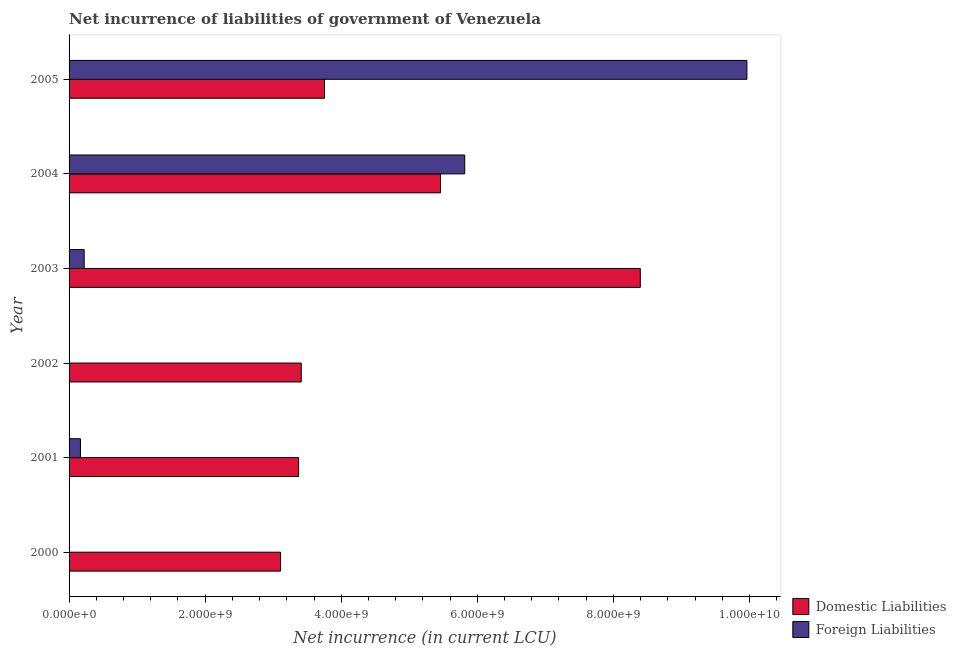How many different coloured bars are there?
Your answer should be very brief. 2. Are the number of bars on each tick of the Y-axis equal?
Your response must be concise. No. How many bars are there on the 1st tick from the top?
Your answer should be very brief. 2. How many bars are there on the 6th tick from the bottom?
Give a very brief answer. 2. In how many cases, is the number of bars for a given year not equal to the number of legend labels?
Offer a very short reply. 2. What is the net incurrence of domestic liabilities in 2000?
Give a very brief answer. 3.11e+09. Across all years, what is the maximum net incurrence of foreign liabilities?
Ensure brevity in your answer.  9.96e+09. Across all years, what is the minimum net incurrence of domestic liabilities?
Provide a succinct answer. 3.11e+09. In which year was the net incurrence of foreign liabilities maximum?
Offer a terse response. 2005. What is the total net incurrence of foreign liabilities in the graph?
Make the answer very short. 1.62e+1. What is the difference between the net incurrence of domestic liabilities in 2000 and that in 2004?
Offer a terse response. -2.35e+09. What is the difference between the net incurrence of foreign liabilities in 2003 and the net incurrence of domestic liabilities in 2002?
Ensure brevity in your answer.  -3.19e+09. What is the average net incurrence of domestic liabilities per year?
Your answer should be very brief. 4.58e+09. In the year 2004, what is the difference between the net incurrence of foreign liabilities and net incurrence of domestic liabilities?
Provide a succinct answer. 3.55e+08. In how many years, is the net incurrence of domestic liabilities greater than 6400000000 LCU?
Keep it short and to the point. 1. Is the difference between the net incurrence of foreign liabilities in 2003 and 2004 greater than the difference between the net incurrence of domestic liabilities in 2003 and 2004?
Offer a terse response. No. What is the difference between the highest and the second highest net incurrence of domestic liabilities?
Your answer should be very brief. 2.94e+09. What is the difference between the highest and the lowest net incurrence of domestic liabilities?
Give a very brief answer. 5.29e+09. In how many years, is the net incurrence of domestic liabilities greater than the average net incurrence of domestic liabilities taken over all years?
Offer a terse response. 2. Is the sum of the net incurrence of foreign liabilities in 2003 and 2005 greater than the maximum net incurrence of domestic liabilities across all years?
Offer a very short reply. Yes. How many bars are there?
Your response must be concise. 10. What is the difference between two consecutive major ticks on the X-axis?
Your response must be concise. 2.00e+09. Are the values on the major ticks of X-axis written in scientific E-notation?
Provide a succinct answer. Yes. Does the graph contain grids?
Your answer should be very brief. No. How many legend labels are there?
Your answer should be compact. 2. What is the title of the graph?
Ensure brevity in your answer.  Net incurrence of liabilities of government of Venezuela. What is the label or title of the X-axis?
Ensure brevity in your answer.  Net incurrence (in current LCU). What is the label or title of the Y-axis?
Your response must be concise. Year. What is the Net incurrence (in current LCU) in Domestic Liabilities in 2000?
Keep it short and to the point. 3.11e+09. What is the Net incurrence (in current LCU) of Foreign Liabilities in 2000?
Provide a succinct answer. 0. What is the Net incurrence (in current LCU) of Domestic Liabilities in 2001?
Keep it short and to the point. 3.37e+09. What is the Net incurrence (in current LCU) of Foreign Liabilities in 2001?
Give a very brief answer. 1.68e+08. What is the Net incurrence (in current LCU) in Domestic Liabilities in 2002?
Give a very brief answer. 3.41e+09. What is the Net incurrence (in current LCU) of Domestic Liabilities in 2003?
Your response must be concise. 8.40e+09. What is the Net incurrence (in current LCU) in Foreign Liabilities in 2003?
Keep it short and to the point. 2.22e+08. What is the Net incurrence (in current LCU) of Domestic Liabilities in 2004?
Give a very brief answer. 5.46e+09. What is the Net incurrence (in current LCU) of Foreign Liabilities in 2004?
Offer a very short reply. 5.81e+09. What is the Net incurrence (in current LCU) of Domestic Liabilities in 2005?
Ensure brevity in your answer.  3.75e+09. What is the Net incurrence (in current LCU) in Foreign Liabilities in 2005?
Ensure brevity in your answer.  9.96e+09. Across all years, what is the maximum Net incurrence (in current LCU) in Domestic Liabilities?
Your answer should be very brief. 8.40e+09. Across all years, what is the maximum Net incurrence (in current LCU) of Foreign Liabilities?
Your response must be concise. 9.96e+09. Across all years, what is the minimum Net incurrence (in current LCU) in Domestic Liabilities?
Your answer should be compact. 3.11e+09. Across all years, what is the minimum Net incurrence (in current LCU) in Foreign Liabilities?
Give a very brief answer. 0. What is the total Net incurrence (in current LCU) in Domestic Liabilities in the graph?
Give a very brief answer. 2.75e+1. What is the total Net incurrence (in current LCU) of Foreign Liabilities in the graph?
Ensure brevity in your answer.  1.62e+1. What is the difference between the Net incurrence (in current LCU) of Domestic Liabilities in 2000 and that in 2001?
Your answer should be compact. -2.65e+08. What is the difference between the Net incurrence (in current LCU) of Domestic Liabilities in 2000 and that in 2002?
Ensure brevity in your answer.  -3.04e+08. What is the difference between the Net incurrence (in current LCU) of Domestic Liabilities in 2000 and that in 2003?
Provide a short and direct response. -5.29e+09. What is the difference between the Net incurrence (in current LCU) in Domestic Liabilities in 2000 and that in 2004?
Keep it short and to the point. -2.35e+09. What is the difference between the Net incurrence (in current LCU) in Domestic Liabilities in 2000 and that in 2005?
Offer a very short reply. -6.45e+08. What is the difference between the Net incurrence (in current LCU) of Domestic Liabilities in 2001 and that in 2002?
Your answer should be very brief. -3.84e+07. What is the difference between the Net incurrence (in current LCU) of Domestic Liabilities in 2001 and that in 2003?
Give a very brief answer. -5.02e+09. What is the difference between the Net incurrence (in current LCU) in Foreign Liabilities in 2001 and that in 2003?
Your response must be concise. -5.43e+07. What is the difference between the Net incurrence (in current LCU) of Domestic Liabilities in 2001 and that in 2004?
Your answer should be compact. -2.09e+09. What is the difference between the Net incurrence (in current LCU) of Foreign Liabilities in 2001 and that in 2004?
Provide a short and direct response. -5.65e+09. What is the difference between the Net incurrence (in current LCU) of Domestic Liabilities in 2001 and that in 2005?
Offer a very short reply. -3.80e+08. What is the difference between the Net incurrence (in current LCU) of Foreign Liabilities in 2001 and that in 2005?
Keep it short and to the point. -9.79e+09. What is the difference between the Net incurrence (in current LCU) of Domestic Liabilities in 2002 and that in 2003?
Ensure brevity in your answer.  -4.98e+09. What is the difference between the Net incurrence (in current LCU) in Domestic Liabilities in 2002 and that in 2004?
Your answer should be very brief. -2.05e+09. What is the difference between the Net incurrence (in current LCU) of Domestic Liabilities in 2002 and that in 2005?
Give a very brief answer. -3.42e+08. What is the difference between the Net incurrence (in current LCU) in Domestic Liabilities in 2003 and that in 2004?
Ensure brevity in your answer.  2.94e+09. What is the difference between the Net incurrence (in current LCU) of Foreign Liabilities in 2003 and that in 2004?
Your response must be concise. -5.59e+09. What is the difference between the Net incurrence (in current LCU) of Domestic Liabilities in 2003 and that in 2005?
Offer a very short reply. 4.64e+09. What is the difference between the Net incurrence (in current LCU) of Foreign Liabilities in 2003 and that in 2005?
Make the answer very short. -9.74e+09. What is the difference between the Net incurrence (in current LCU) in Domestic Liabilities in 2004 and that in 2005?
Your response must be concise. 1.71e+09. What is the difference between the Net incurrence (in current LCU) in Foreign Liabilities in 2004 and that in 2005?
Your answer should be compact. -4.15e+09. What is the difference between the Net incurrence (in current LCU) of Domestic Liabilities in 2000 and the Net incurrence (in current LCU) of Foreign Liabilities in 2001?
Make the answer very short. 2.94e+09. What is the difference between the Net incurrence (in current LCU) in Domestic Liabilities in 2000 and the Net incurrence (in current LCU) in Foreign Liabilities in 2003?
Ensure brevity in your answer.  2.89e+09. What is the difference between the Net incurrence (in current LCU) in Domestic Liabilities in 2000 and the Net incurrence (in current LCU) in Foreign Liabilities in 2004?
Your answer should be very brief. -2.71e+09. What is the difference between the Net incurrence (in current LCU) in Domestic Liabilities in 2000 and the Net incurrence (in current LCU) in Foreign Liabilities in 2005?
Provide a short and direct response. -6.85e+09. What is the difference between the Net incurrence (in current LCU) of Domestic Liabilities in 2001 and the Net incurrence (in current LCU) of Foreign Liabilities in 2003?
Your answer should be very brief. 3.15e+09. What is the difference between the Net incurrence (in current LCU) of Domestic Liabilities in 2001 and the Net incurrence (in current LCU) of Foreign Liabilities in 2004?
Your answer should be compact. -2.44e+09. What is the difference between the Net incurrence (in current LCU) in Domestic Liabilities in 2001 and the Net incurrence (in current LCU) in Foreign Liabilities in 2005?
Provide a short and direct response. -6.59e+09. What is the difference between the Net incurrence (in current LCU) of Domestic Liabilities in 2002 and the Net incurrence (in current LCU) of Foreign Liabilities in 2003?
Offer a terse response. 3.19e+09. What is the difference between the Net incurrence (in current LCU) of Domestic Liabilities in 2002 and the Net incurrence (in current LCU) of Foreign Liabilities in 2004?
Offer a terse response. -2.40e+09. What is the difference between the Net incurrence (in current LCU) of Domestic Liabilities in 2002 and the Net incurrence (in current LCU) of Foreign Liabilities in 2005?
Keep it short and to the point. -6.55e+09. What is the difference between the Net incurrence (in current LCU) in Domestic Liabilities in 2003 and the Net incurrence (in current LCU) in Foreign Liabilities in 2004?
Give a very brief answer. 2.58e+09. What is the difference between the Net incurrence (in current LCU) of Domestic Liabilities in 2003 and the Net incurrence (in current LCU) of Foreign Liabilities in 2005?
Make the answer very short. -1.57e+09. What is the difference between the Net incurrence (in current LCU) in Domestic Liabilities in 2004 and the Net incurrence (in current LCU) in Foreign Liabilities in 2005?
Make the answer very short. -4.50e+09. What is the average Net incurrence (in current LCU) in Domestic Liabilities per year?
Provide a short and direct response. 4.58e+09. What is the average Net incurrence (in current LCU) of Foreign Liabilities per year?
Give a very brief answer. 2.69e+09. In the year 2001, what is the difference between the Net incurrence (in current LCU) of Domestic Liabilities and Net incurrence (in current LCU) of Foreign Liabilities?
Ensure brevity in your answer.  3.21e+09. In the year 2003, what is the difference between the Net incurrence (in current LCU) in Domestic Liabilities and Net incurrence (in current LCU) in Foreign Liabilities?
Ensure brevity in your answer.  8.17e+09. In the year 2004, what is the difference between the Net incurrence (in current LCU) in Domestic Liabilities and Net incurrence (in current LCU) in Foreign Liabilities?
Keep it short and to the point. -3.55e+08. In the year 2005, what is the difference between the Net incurrence (in current LCU) in Domestic Liabilities and Net incurrence (in current LCU) in Foreign Liabilities?
Provide a succinct answer. -6.21e+09. What is the ratio of the Net incurrence (in current LCU) of Domestic Liabilities in 2000 to that in 2001?
Offer a terse response. 0.92. What is the ratio of the Net incurrence (in current LCU) of Domestic Liabilities in 2000 to that in 2002?
Offer a very short reply. 0.91. What is the ratio of the Net incurrence (in current LCU) in Domestic Liabilities in 2000 to that in 2003?
Make the answer very short. 0.37. What is the ratio of the Net incurrence (in current LCU) of Domestic Liabilities in 2000 to that in 2004?
Your response must be concise. 0.57. What is the ratio of the Net incurrence (in current LCU) in Domestic Liabilities in 2000 to that in 2005?
Offer a very short reply. 0.83. What is the ratio of the Net incurrence (in current LCU) in Domestic Liabilities in 2001 to that in 2002?
Your answer should be compact. 0.99. What is the ratio of the Net incurrence (in current LCU) in Domestic Liabilities in 2001 to that in 2003?
Make the answer very short. 0.4. What is the ratio of the Net incurrence (in current LCU) of Foreign Liabilities in 2001 to that in 2003?
Your answer should be compact. 0.76. What is the ratio of the Net incurrence (in current LCU) of Domestic Liabilities in 2001 to that in 2004?
Ensure brevity in your answer.  0.62. What is the ratio of the Net incurrence (in current LCU) in Foreign Liabilities in 2001 to that in 2004?
Provide a succinct answer. 0.03. What is the ratio of the Net incurrence (in current LCU) of Domestic Liabilities in 2001 to that in 2005?
Provide a succinct answer. 0.9. What is the ratio of the Net incurrence (in current LCU) in Foreign Liabilities in 2001 to that in 2005?
Ensure brevity in your answer.  0.02. What is the ratio of the Net incurrence (in current LCU) in Domestic Liabilities in 2002 to that in 2003?
Offer a very short reply. 0.41. What is the ratio of the Net incurrence (in current LCU) in Domestic Liabilities in 2002 to that in 2005?
Make the answer very short. 0.91. What is the ratio of the Net incurrence (in current LCU) of Domestic Liabilities in 2003 to that in 2004?
Your answer should be very brief. 1.54. What is the ratio of the Net incurrence (in current LCU) in Foreign Liabilities in 2003 to that in 2004?
Ensure brevity in your answer.  0.04. What is the ratio of the Net incurrence (in current LCU) in Domestic Liabilities in 2003 to that in 2005?
Your answer should be very brief. 2.24. What is the ratio of the Net incurrence (in current LCU) of Foreign Liabilities in 2003 to that in 2005?
Your answer should be very brief. 0.02. What is the ratio of the Net incurrence (in current LCU) in Domestic Liabilities in 2004 to that in 2005?
Offer a very short reply. 1.45. What is the ratio of the Net incurrence (in current LCU) in Foreign Liabilities in 2004 to that in 2005?
Offer a very short reply. 0.58. What is the difference between the highest and the second highest Net incurrence (in current LCU) in Domestic Liabilities?
Offer a terse response. 2.94e+09. What is the difference between the highest and the second highest Net incurrence (in current LCU) of Foreign Liabilities?
Your response must be concise. 4.15e+09. What is the difference between the highest and the lowest Net incurrence (in current LCU) of Domestic Liabilities?
Your response must be concise. 5.29e+09. What is the difference between the highest and the lowest Net incurrence (in current LCU) in Foreign Liabilities?
Give a very brief answer. 9.96e+09. 